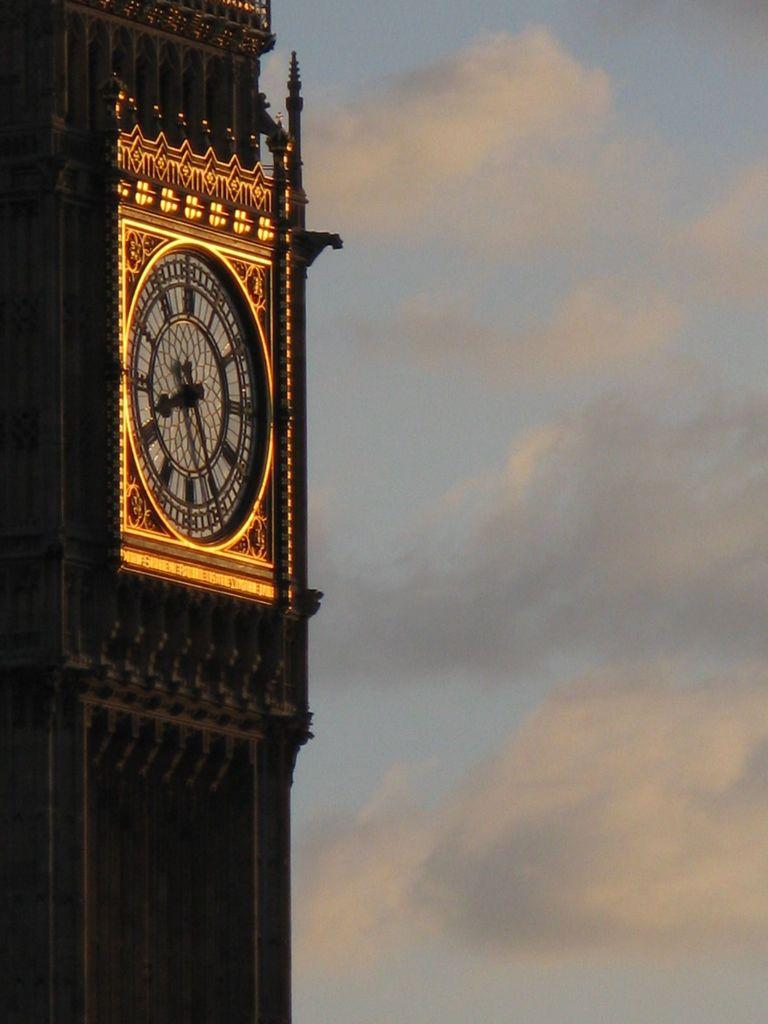What is the main focus of the image? The center of the image contains the sky and clouds. What structure can be seen in the image? There is a clock tower in the image. Are there any other objects or features in the image? Yes, there are other objects in the image. What can be found on the clock tower? There is artwork on the clock tower. Can you see a goose walking along the tracks in the image? There is no goose or train tracks present in the image. 